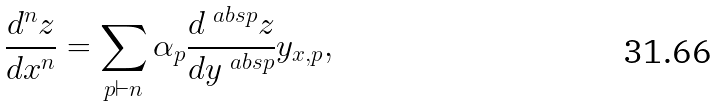<formula> <loc_0><loc_0><loc_500><loc_500>\frac { d ^ { n } z } { d x ^ { n } } = \sum _ { p \vdash n } \alpha _ { p } \frac { d ^ { \ a b s p } z } { d y ^ { \ a b s p } } y _ { x , p } ,</formula> 